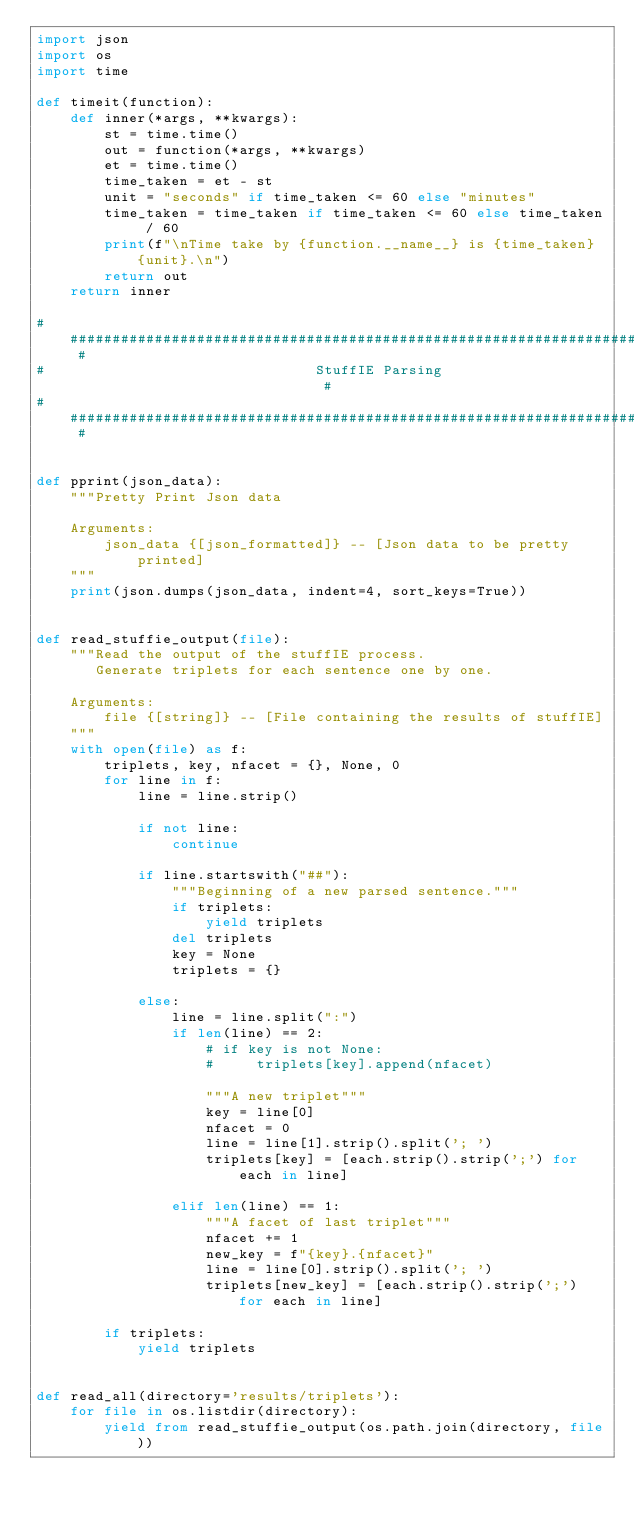Convert code to text. <code><loc_0><loc_0><loc_500><loc_500><_Python_>import json
import os
import time

def timeit(function):
    def inner(*args, **kwargs):
        st = time.time()
        out = function(*args, **kwargs)
        et = time.time()
        time_taken = et - st
        unit = "seconds" if time_taken <= 60 else "minutes"
        time_taken = time_taken if time_taken <= 60 else time_taken / 60
        print(f"\nTime take by {function.__name__} is {time_taken} {unit}.\n")
        return out
    return inner

# ############################################################################ #
#                                StuffIE Parsing                               #
# ############################################################################ #


def pprint(json_data):
    """Pretty Print Json data

    Arguments:
        json_data {[json_formatted]} -- [Json data to be pretty printed]
    """
    print(json.dumps(json_data, indent=4, sort_keys=True))


def read_stuffie_output(file):
    """Read the output of the stuffIE process.
       Generate triplets for each sentence one by one.

    Arguments:
        file {[string]} -- [File containing the results of stuffIE]
    """
    with open(file) as f:
        triplets, key, nfacet = {}, None, 0
        for line in f:
            line = line.strip()

            if not line:
                continue

            if line.startswith("##"):
                """Beginning of a new parsed sentence."""
                if triplets:
                    yield triplets
                del triplets
                key = None
                triplets = {}

            else:
                line = line.split(":")
                if len(line) == 2:
                    # if key is not None:
                    #     triplets[key].append(nfacet)

                    """A new triplet"""
                    key = line[0]
                    nfacet = 0
                    line = line[1].strip().split('; ')
                    triplets[key] = [each.strip().strip(';') for each in line]

                elif len(line) == 1:
                    """A facet of last triplet"""
                    nfacet += 1
                    new_key = f"{key}.{nfacet}"
                    line = line[0].strip().split('; ')
                    triplets[new_key] = [each.strip().strip(';') for each in line]

        if triplets:
            yield triplets


def read_all(directory='results/triplets'):
    for file in os.listdir(directory):
        yield from read_stuffie_output(os.path.join(directory, file))
</code> 